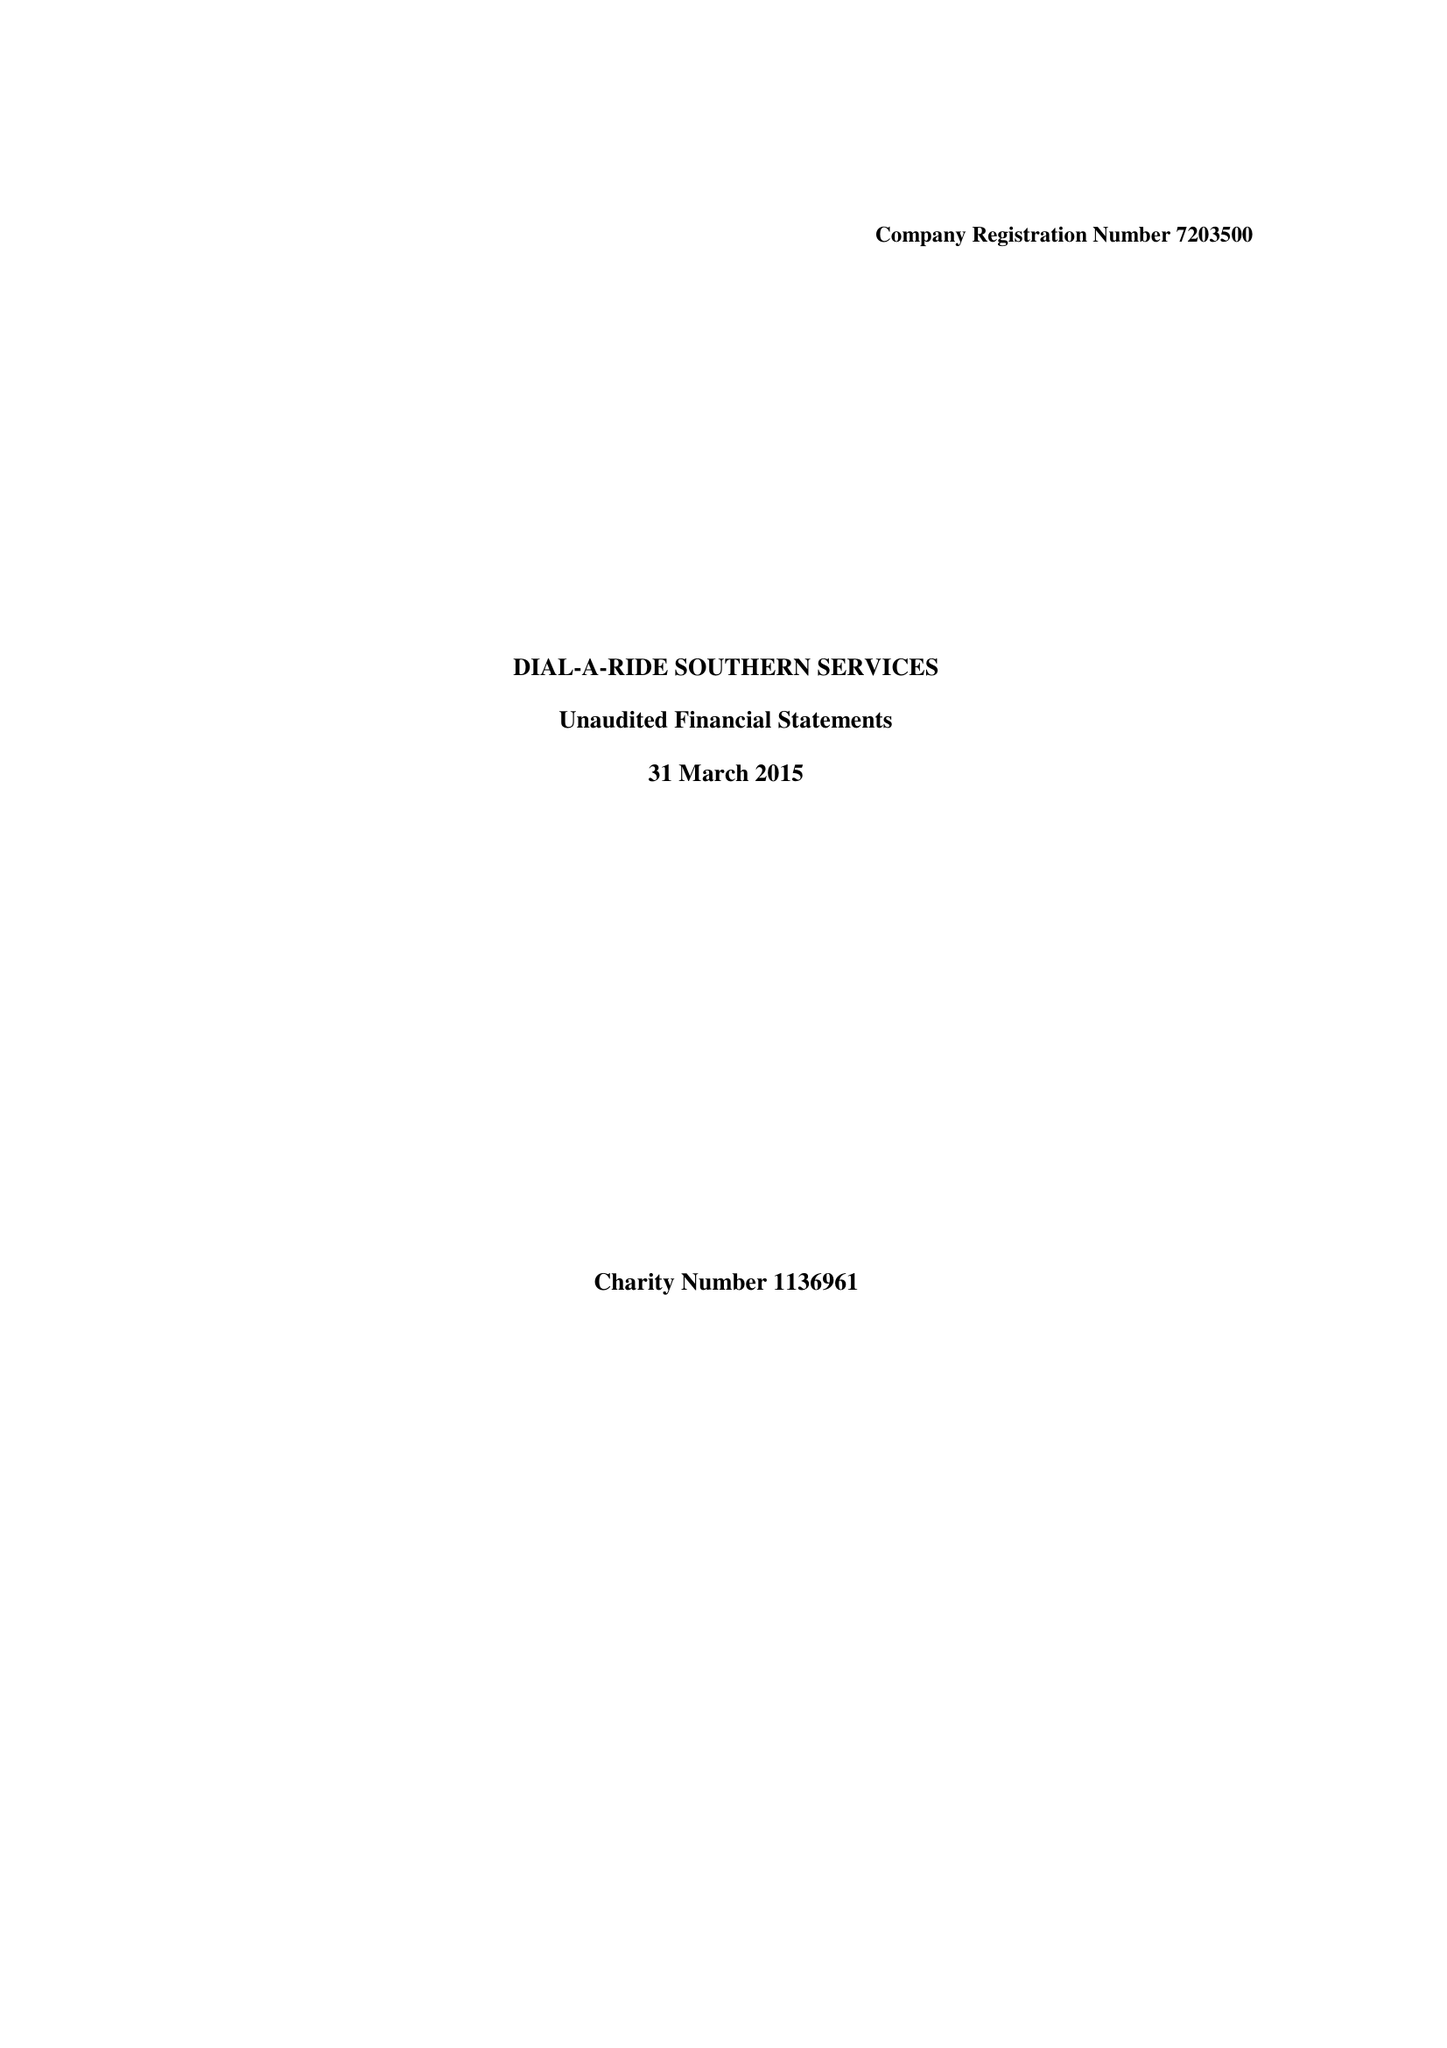What is the value for the spending_annually_in_british_pounds?
Answer the question using a single word or phrase. 109088.00 